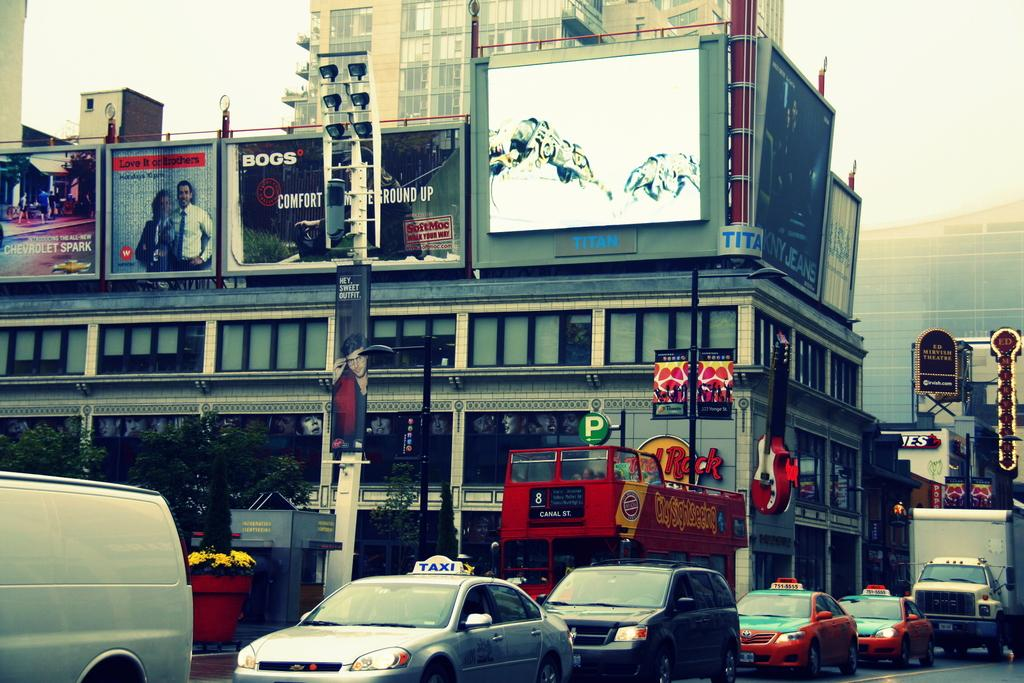Provide a one-sentence caption for the provided image. A city street scene has a taxi and a double-decker bus. 